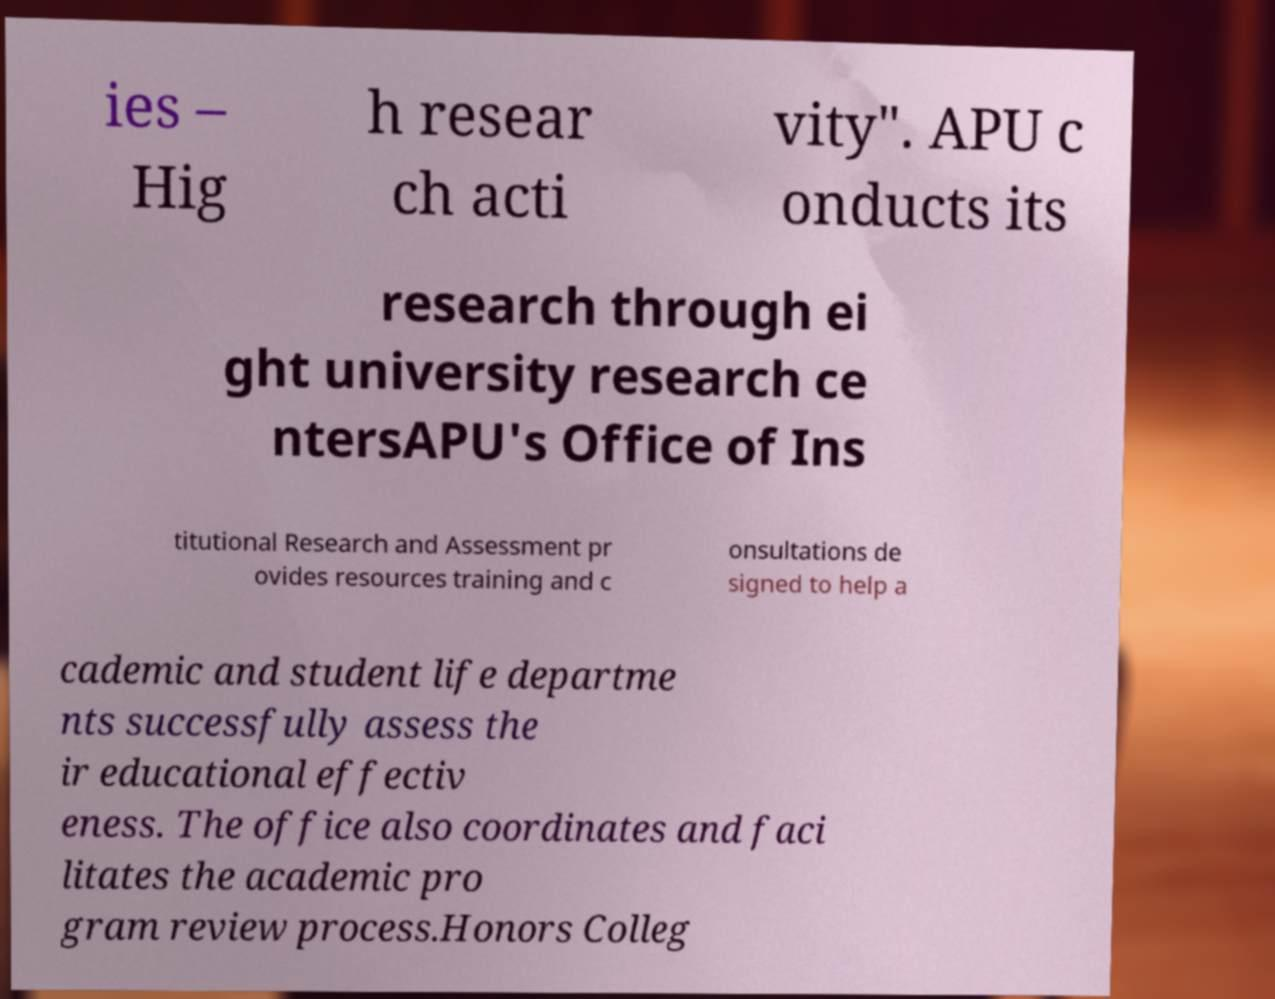For documentation purposes, I need the text within this image transcribed. Could you provide that? ies – Hig h resear ch acti vity". APU c onducts its research through ei ght university research ce ntersAPU's Office of Ins titutional Research and Assessment pr ovides resources training and c onsultations de signed to help a cademic and student life departme nts successfully assess the ir educational effectiv eness. The office also coordinates and faci litates the academic pro gram review process.Honors Colleg 